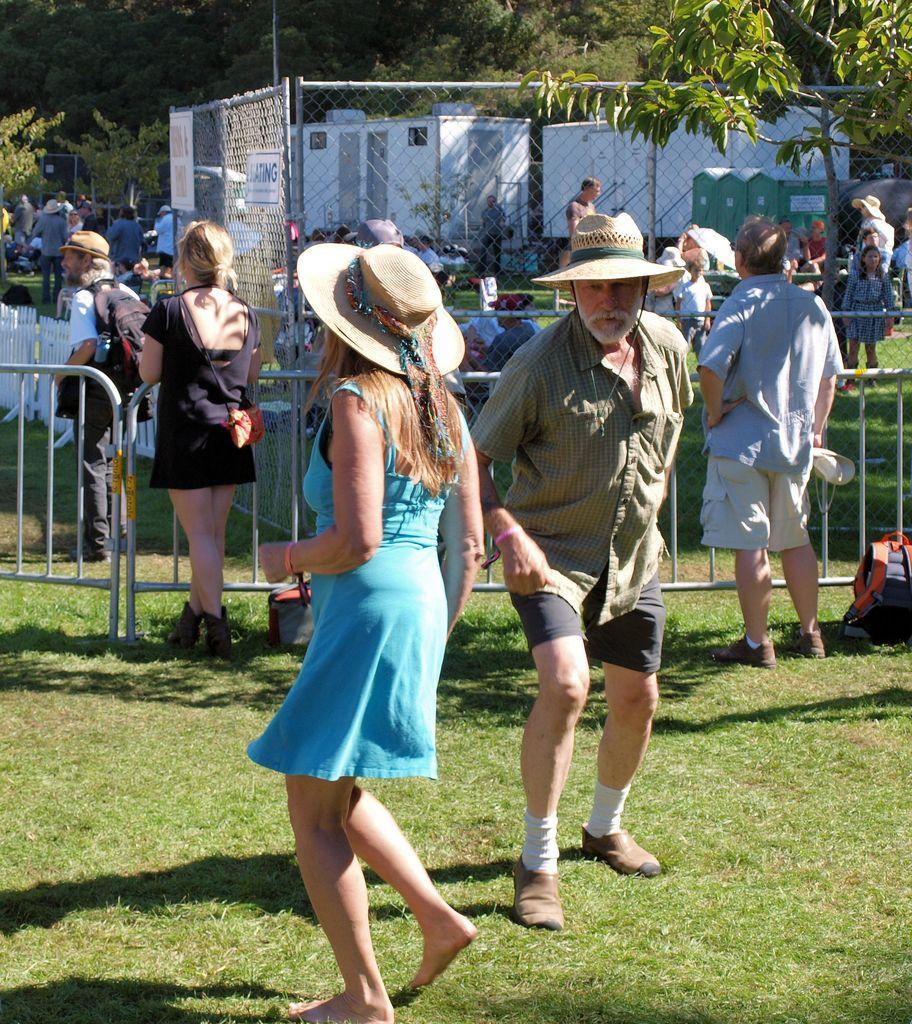How would you summarize this image in a sentence or two? This is looking like a garden. Here I can see a man and a woman wearing caps on their heads and standing on the ground. It seems like they are dancing. On the ground, I can see the grass. At the back of these people there are two more persons standing facing towards the back side. In front of these people there is a railing. In the background, I can see many people and also there is a net fencing and trees. On the right side there is a bag placed on the ground. 